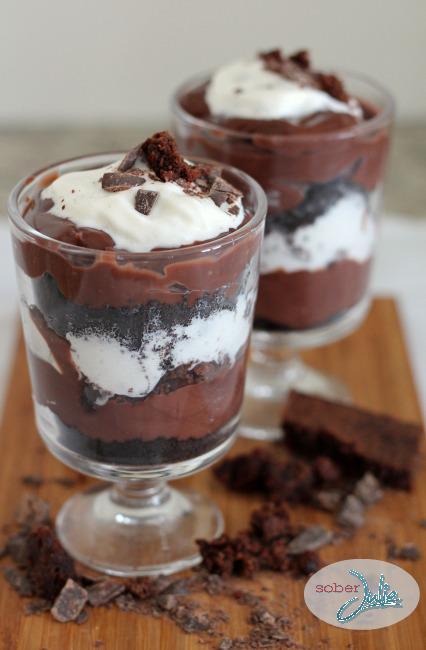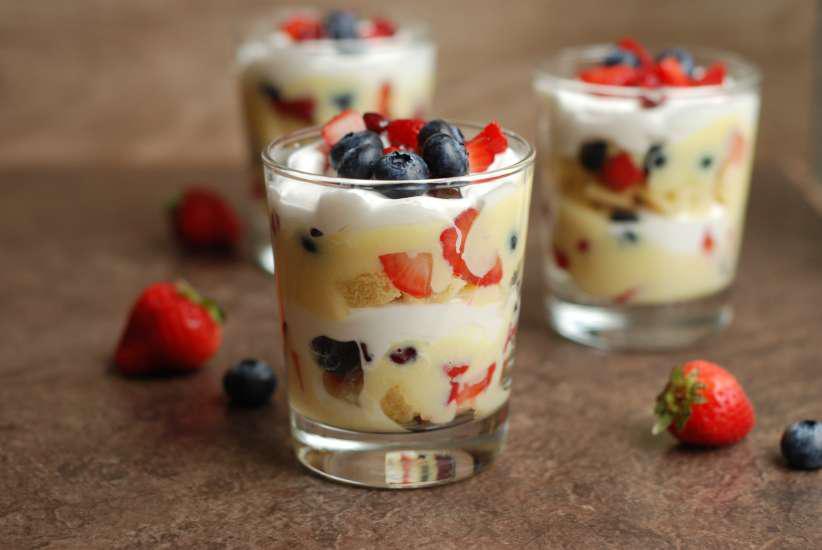The first image is the image on the left, the second image is the image on the right. Considering the images on both sides, is "There are two servings of desserts in the image on the right." valid? Answer yes or no. No. 